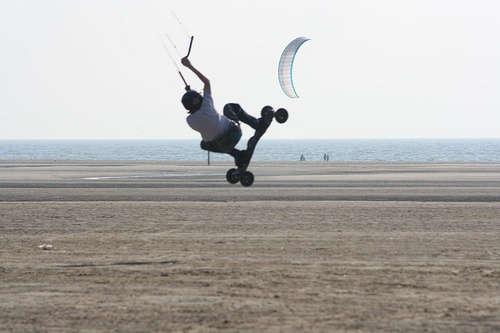Describe the objects in this image and their specific colors. I can see people in white, black, gray, and darkgray tones, skateboard in white, black, gray, and darkgray tones, kite in white, lightgray, darkgray, and lightblue tones, people in white, darkgray, and gray tones, and people in white, gray, and darkgray tones in this image. 